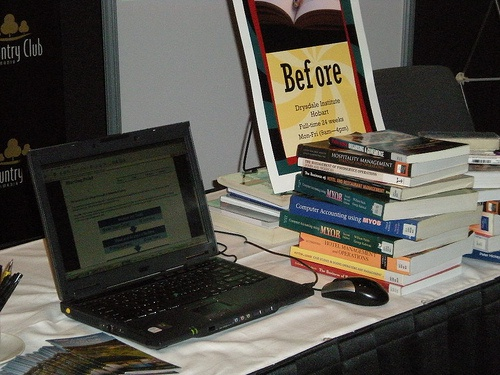Describe the objects in this image and their specific colors. I can see laptop in black, darkgreen, and gray tones, book in black, darkgray, tan, and navy tones, book in black, darkgray, navy, and darkblue tones, book in black, gray, darkgray, and lightgray tones, and mouse in black, gray, and maroon tones in this image. 